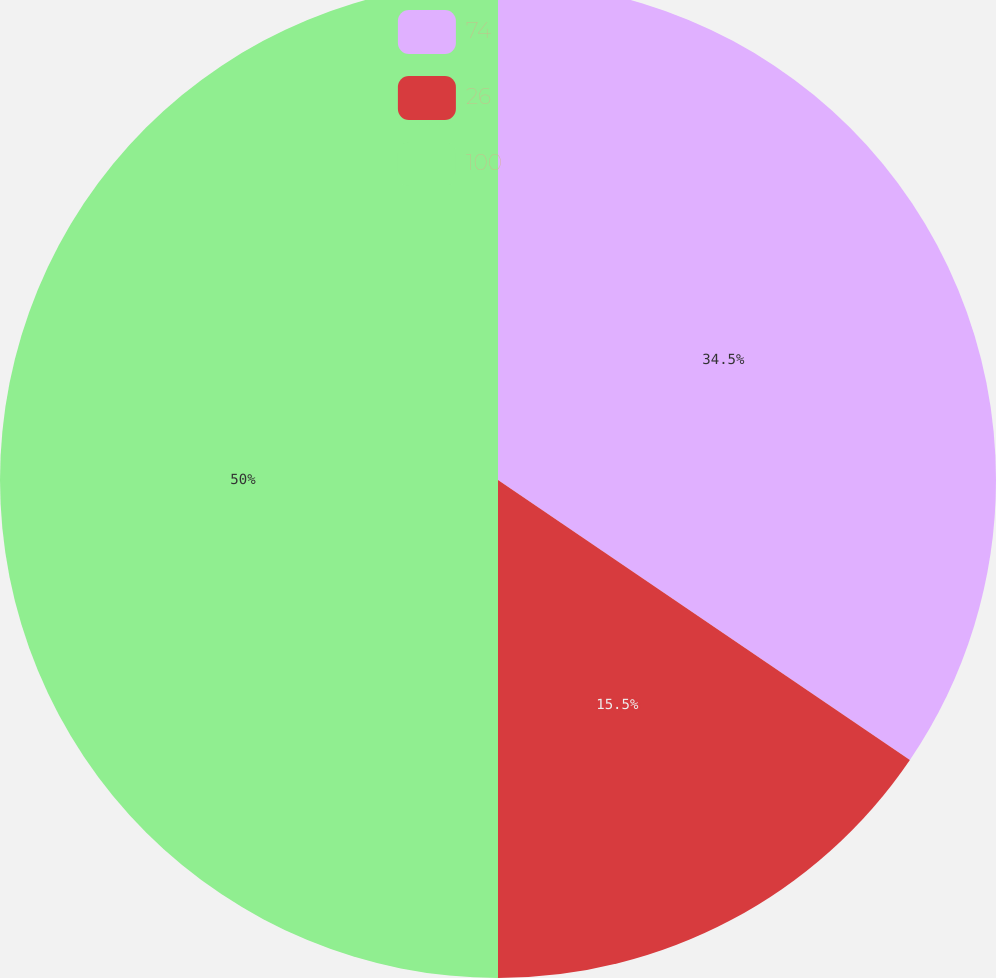<chart> <loc_0><loc_0><loc_500><loc_500><pie_chart><fcel>74<fcel>26<fcel>100<nl><fcel>34.5%<fcel>15.5%<fcel>50.0%<nl></chart> 